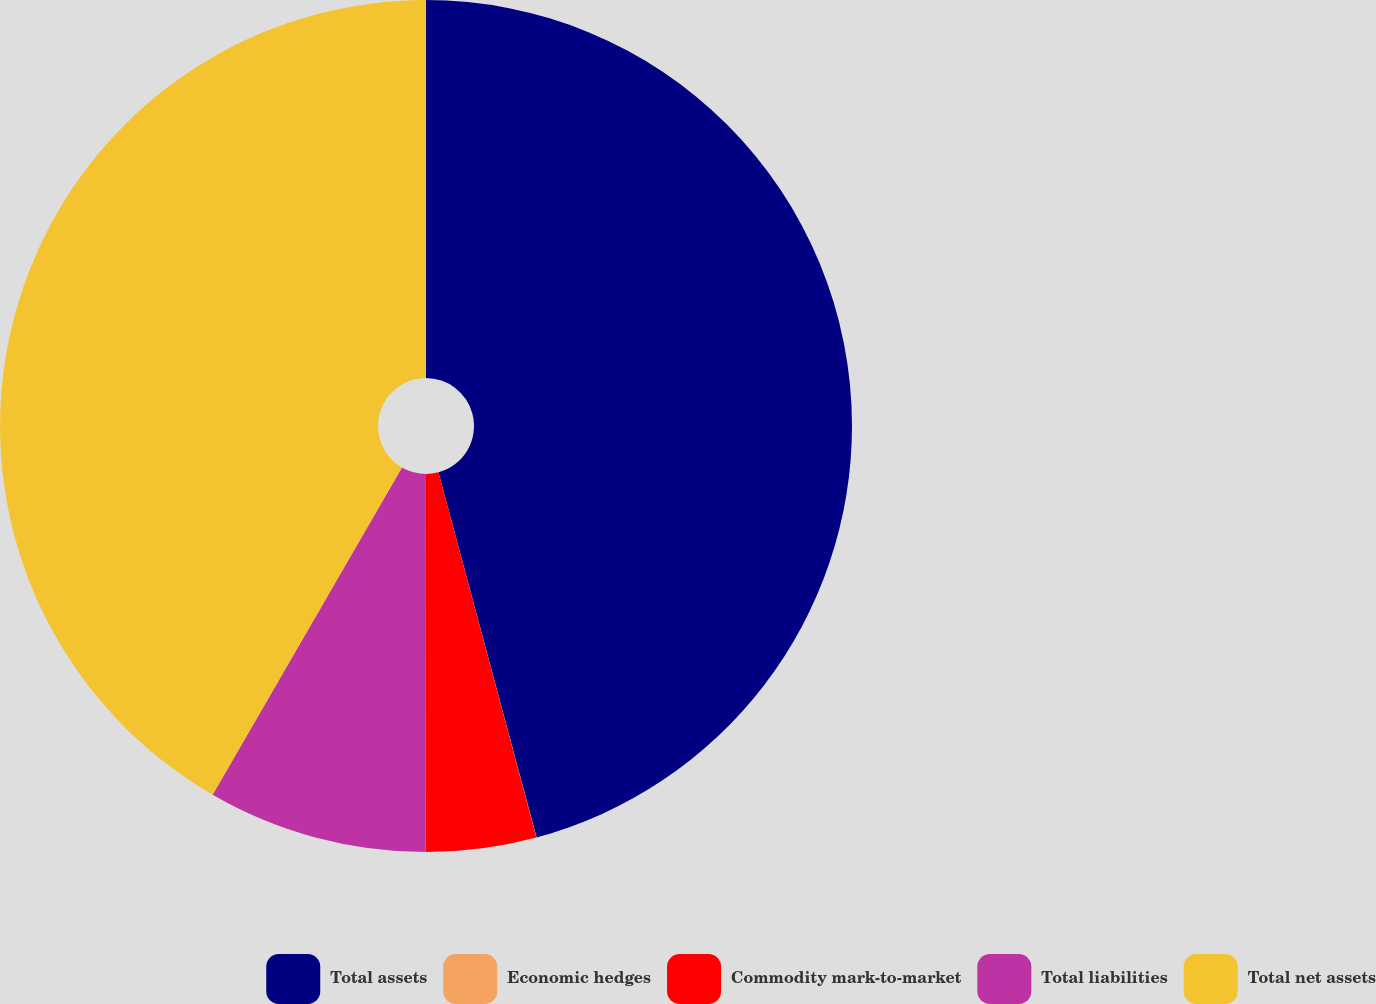<chart> <loc_0><loc_0><loc_500><loc_500><pie_chart><fcel>Total assets<fcel>Economic hedges<fcel>Commodity mark-to-market<fcel>Total liabilities<fcel>Total net assets<nl><fcel>45.82%<fcel>0.01%<fcel>4.18%<fcel>8.34%<fcel>41.65%<nl></chart> 